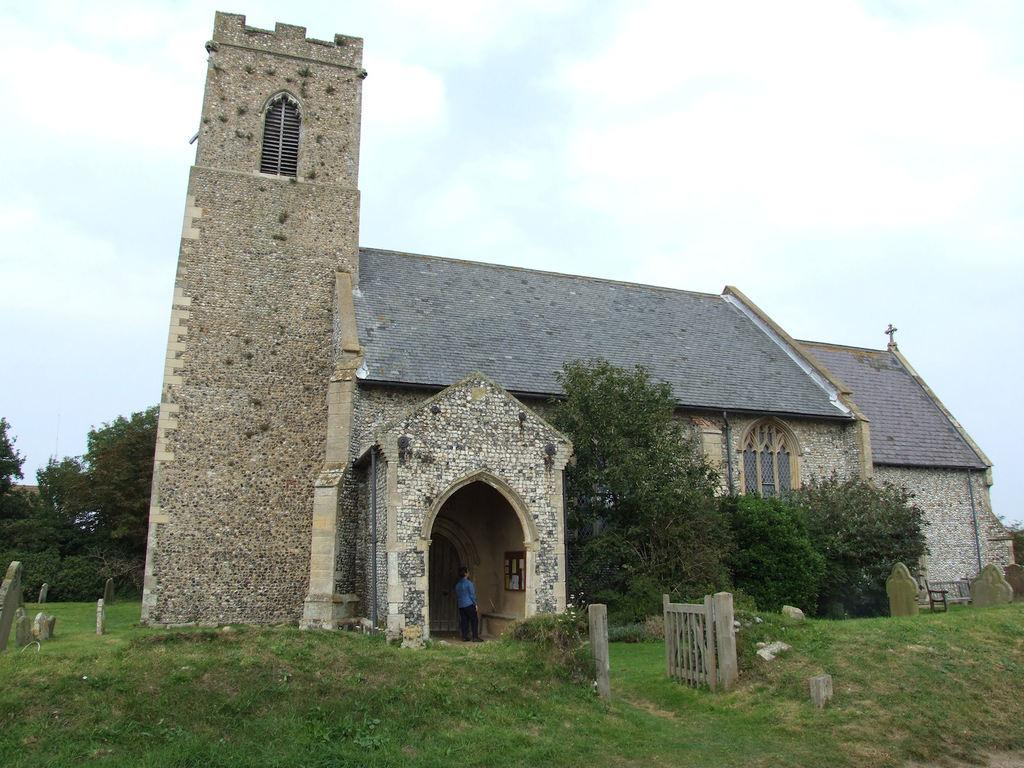What type of structure is present in the image? There is a building with windows in the image. What natural elements can be seen in the image? There are trees and grass in the image. Is there a person in the image? Yes, there is a person standing in the image. What can be seen in the background of the image? The sky with clouds is visible in the background of the image. What type of regret can be seen on the person's face in the image? There is no indication of regret on the person's face in the image. What type of playground equipment is present in the image? There is no playground equipment present in the image. 